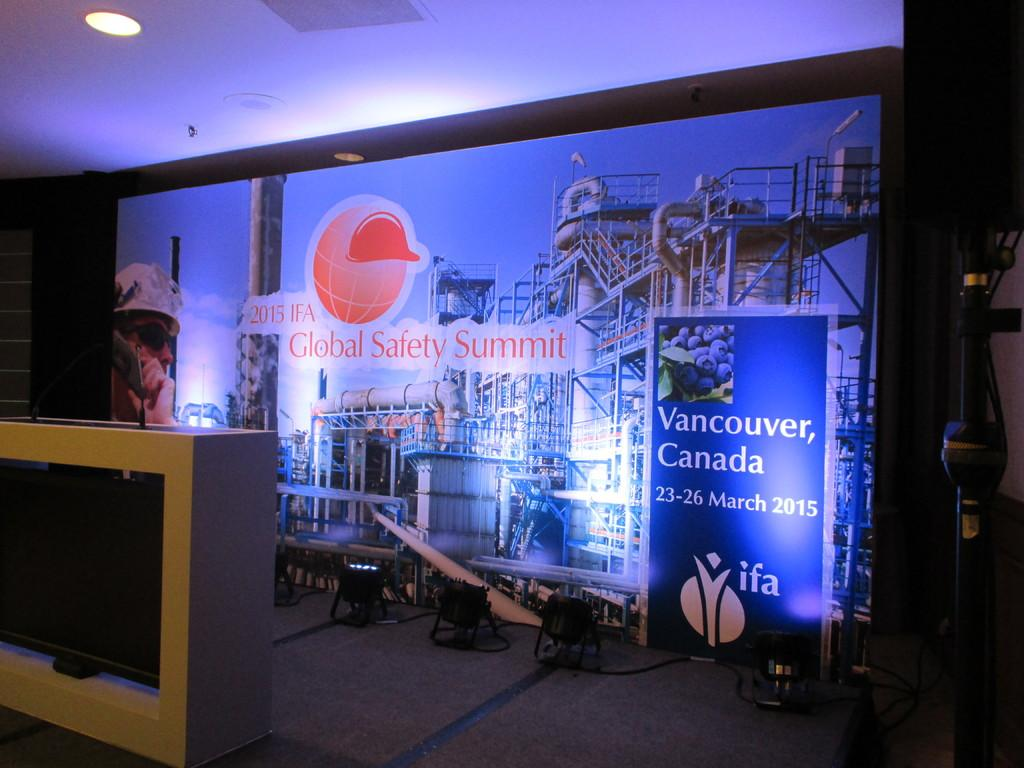<image>
Render a clear and concise summary of the photo. A display advertising the Global Safety Summit being held in Vancouver, Canada. 